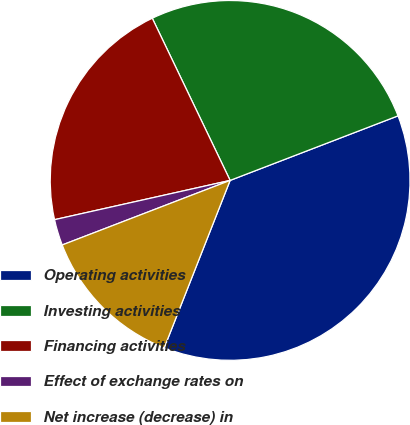<chart> <loc_0><loc_0><loc_500><loc_500><pie_chart><fcel>Operating activities<fcel>Investing activities<fcel>Financing activities<fcel>Effect of exchange rates on<fcel>Net increase (decrease) in<nl><fcel>36.81%<fcel>26.28%<fcel>21.38%<fcel>2.34%<fcel>13.19%<nl></chart> 